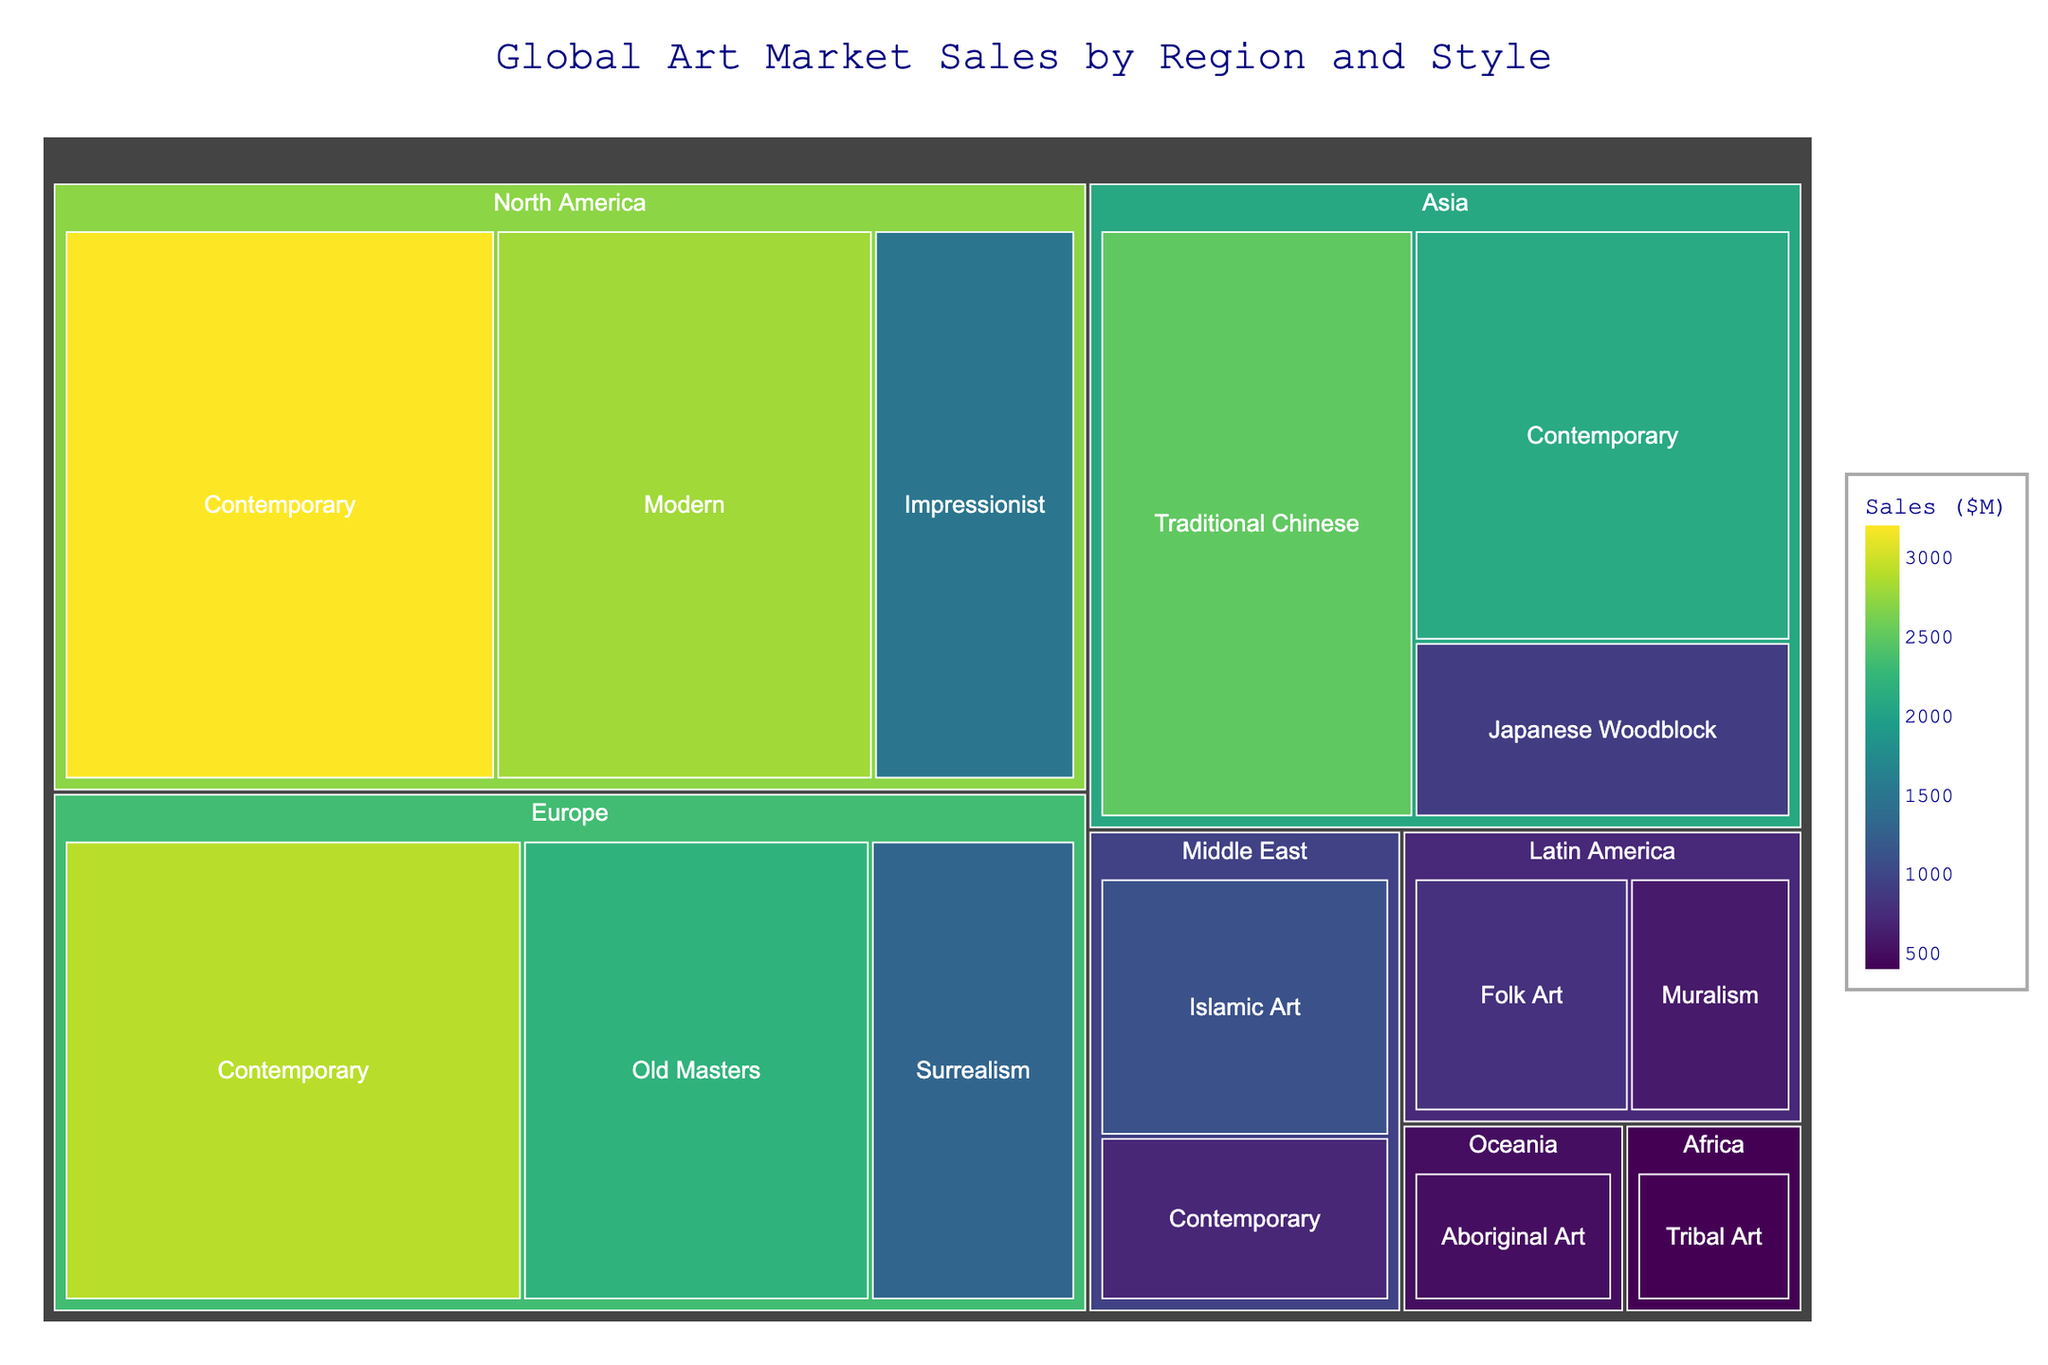What is the title of the treemap? Look for the textual information usually placed at the top of the treemap. The title is "Global Art Market Sales by Region and Style".
Answer: Global Art Market Sales by Region and Style Which region has the highest sales in Contemporary art? Observe the sizes of the rectangles corresponding to Contemporary art in each region. North America's Contemporary art rectangle is the largest.
Answer: North America What is the total sales amount for Europe? Identify and sum the sales values of all artistic styles in Europe: Contemporary (2900) + Old Masters (2200) + Surrealism (1300). The total sales for Europe is 6400.
Answer: 6400 Which artistic style has the lowest sales worldwide? Compare the sizes of all rectangles in the treemap and find the smallest one. The lowest sales are for Tribal Art from Africa with 400.
Answer: Tribal Art Which region has the most diverse artistic styles represented? Count the number of different artistic styles in each region. North America, Europe, and Asia have more styles than other regions, with North America and Europe having three styles each, while Asia also has three. The three regions have the same diversity.
Answer: North America, Europe, Asia How do the sales of Islamic Art in the Middle East compare to Contemporary art in the same region? Compare the sizes of the rectangles or sales values for the two styles within the Middle East. Islamic Art has 1100 in sales, while Contemporary art has 700.
Answer: Islamic Art has higher sales What is the total sales amount for Contemporary art worldwide? Sum the sales values of Contemporary art across all regions: North America (3200) + Europe (2900) + Asia (2100) + Middle East (700). The total sales for Contemporary art is 8900.
Answer: 8900 Which region has the least total sales and what style contributes to it? Identify the smallest total sales sum by region: Oceania (500), which comes from Aboriginal Art.
Answer: Oceania with Aboriginal Art What percentage of total Asian sales is from Traditional Chinese art? Calculate the percentage of Traditional Chinese sales out of total Asian sales: (2500 / 5500) * 100. The percentage is about 45.45%.
Answer: 45.45% Which has higher sales, Muralism in Latin America or Surrealism in Europe? Compare the sales values of the two styles: Muralism (600) and Surrealism (1300). Surrealism has higher sales.
Answer: Surrealism 